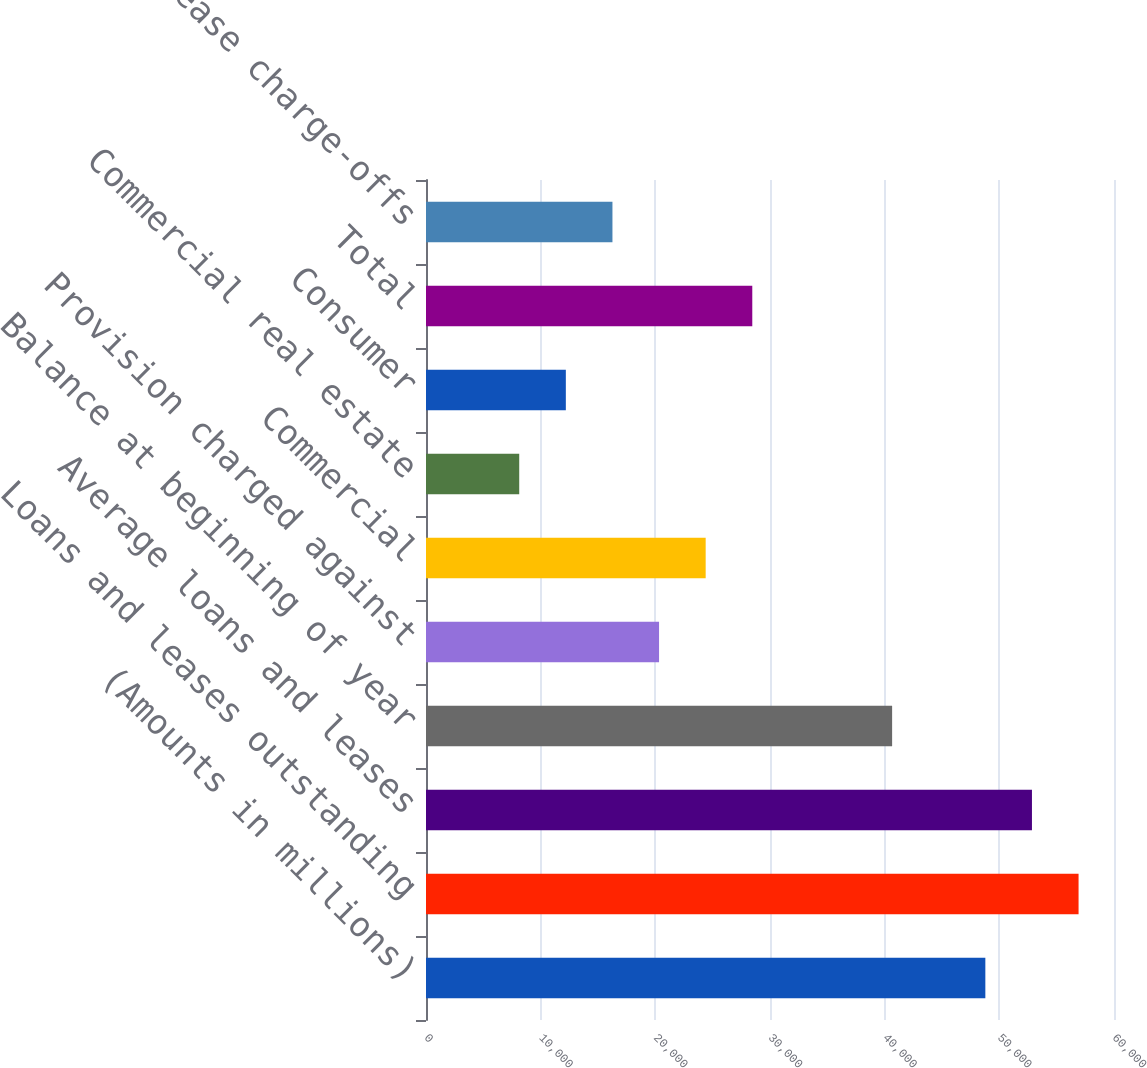Convert chart. <chart><loc_0><loc_0><loc_500><loc_500><bar_chart><fcel>(Amounts in millions)<fcel>Loans and leases outstanding<fcel>Average loans and leases<fcel>Balance at beginning of year<fcel>Provision charged against<fcel>Commercial<fcel>Commercial real estate<fcel>Consumer<fcel>Total<fcel>Net loan and lease charge-offs<nl><fcel>48780<fcel>56910<fcel>52845<fcel>40650<fcel>20325<fcel>24390<fcel>8130.08<fcel>12195.1<fcel>28455<fcel>16260.1<nl></chart> 